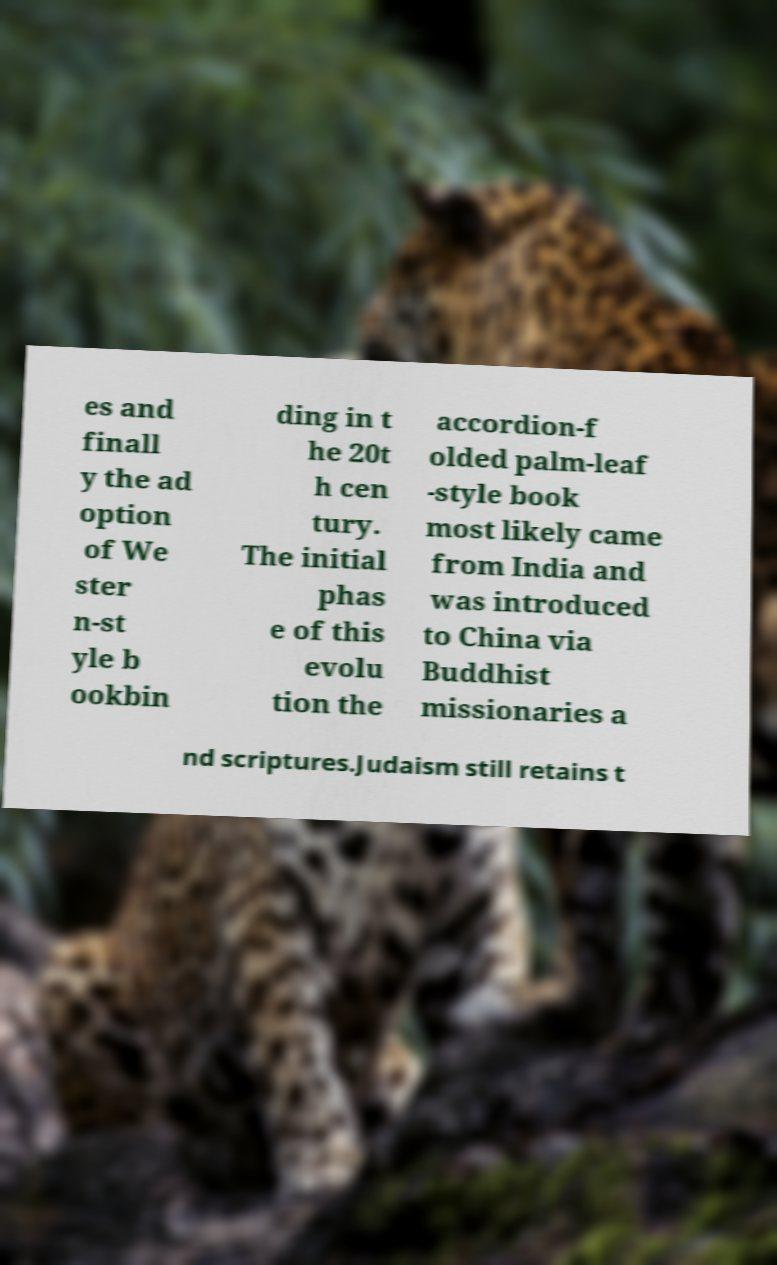What messages or text are displayed in this image? I need them in a readable, typed format. es and finall y the ad option of We ster n-st yle b ookbin ding in t he 20t h cen tury. The initial phas e of this evolu tion the accordion-f olded palm-leaf -style book most likely came from India and was introduced to China via Buddhist missionaries a nd scriptures.Judaism still retains t 